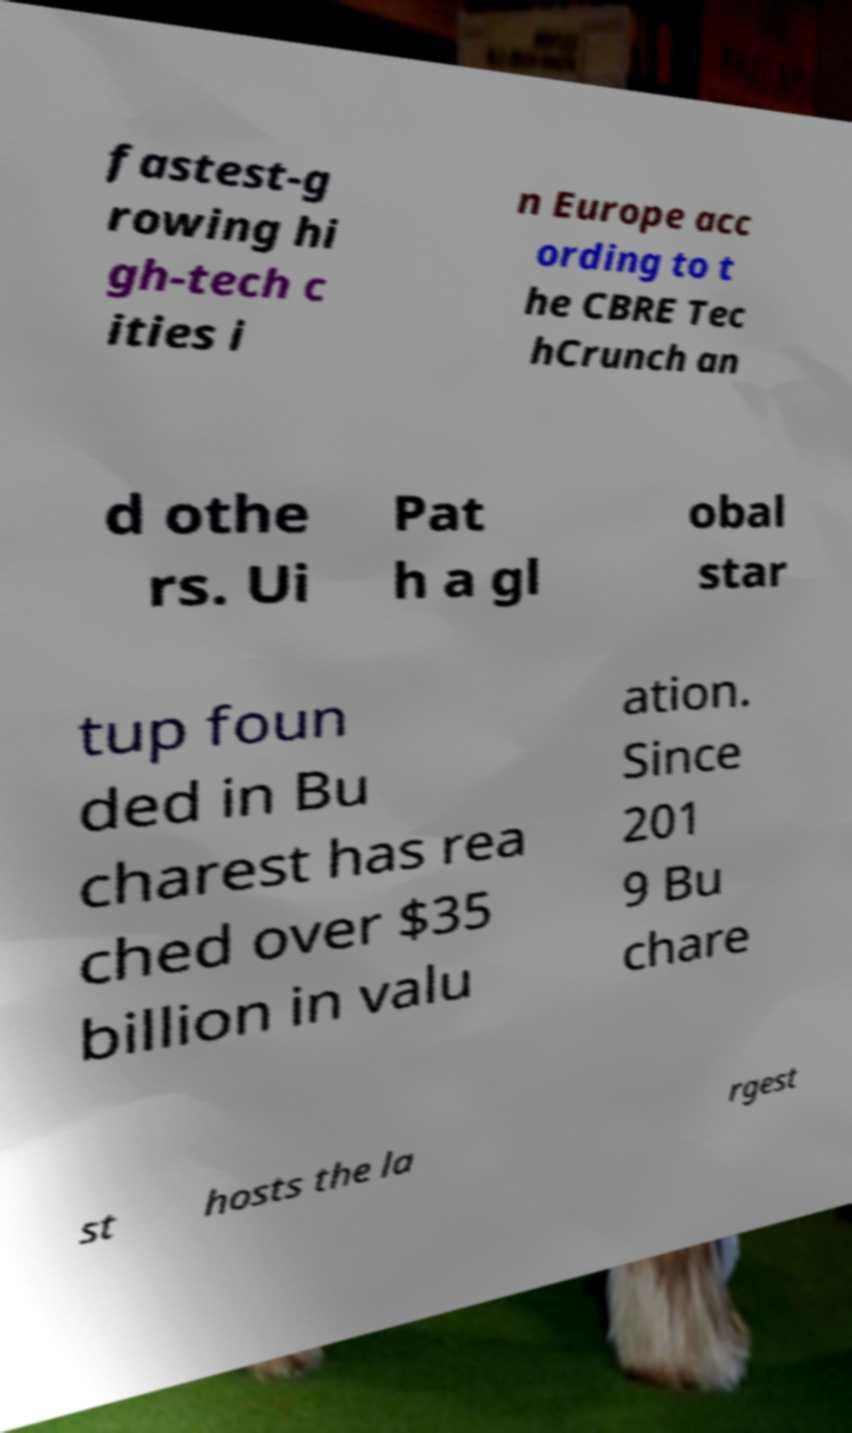There's text embedded in this image that I need extracted. Can you transcribe it verbatim? fastest-g rowing hi gh-tech c ities i n Europe acc ording to t he CBRE Tec hCrunch an d othe rs. Ui Pat h a gl obal star tup foun ded in Bu charest has rea ched over $35 billion in valu ation. Since 201 9 Bu chare st hosts the la rgest 